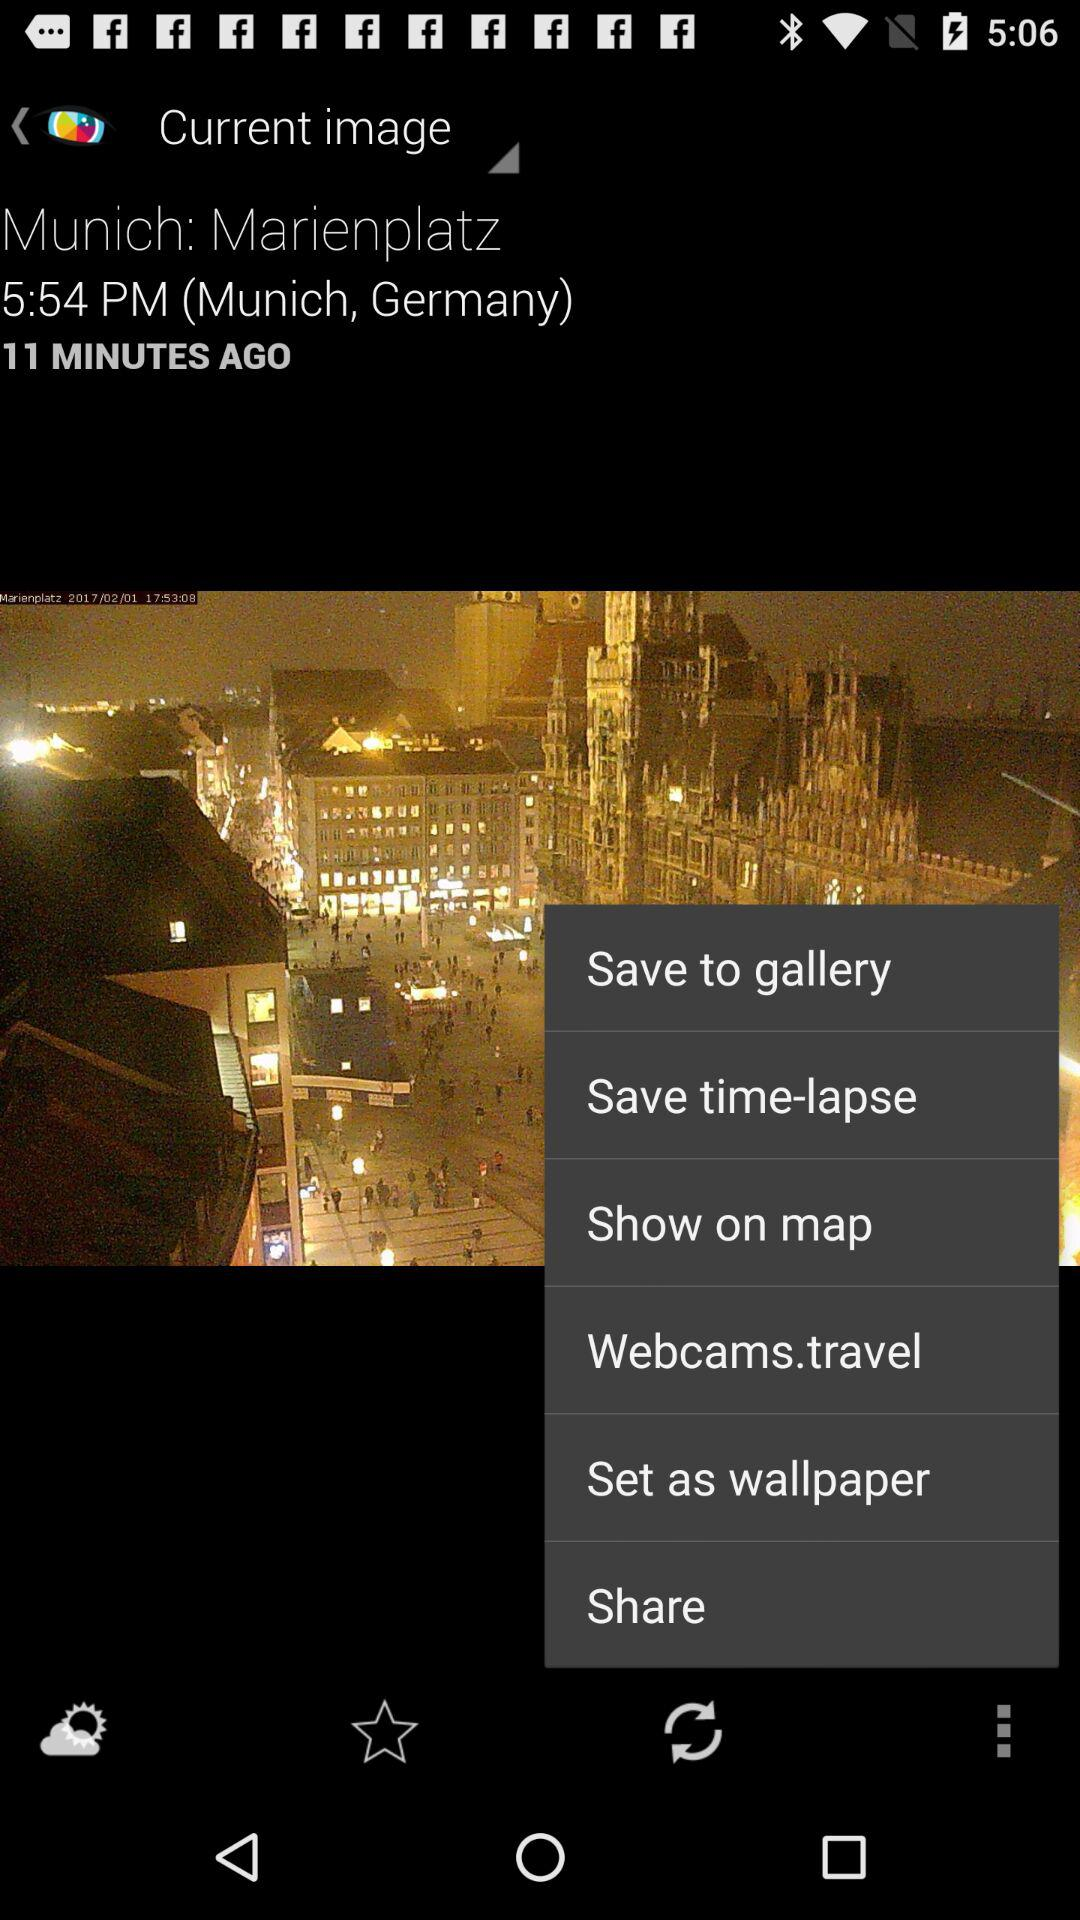How many minutes ago was the image captured? The image was captured 11 minutes ago. 